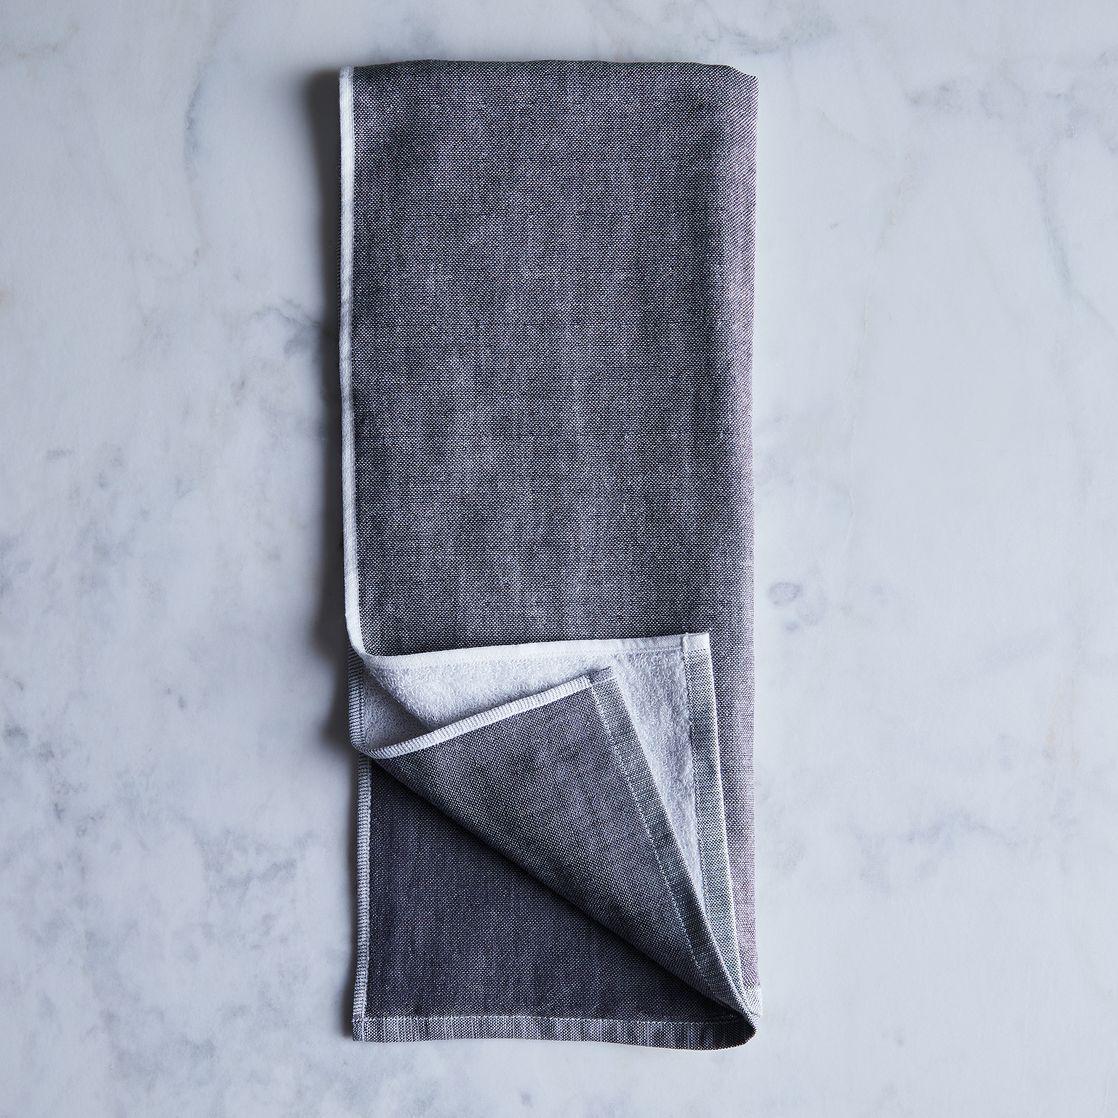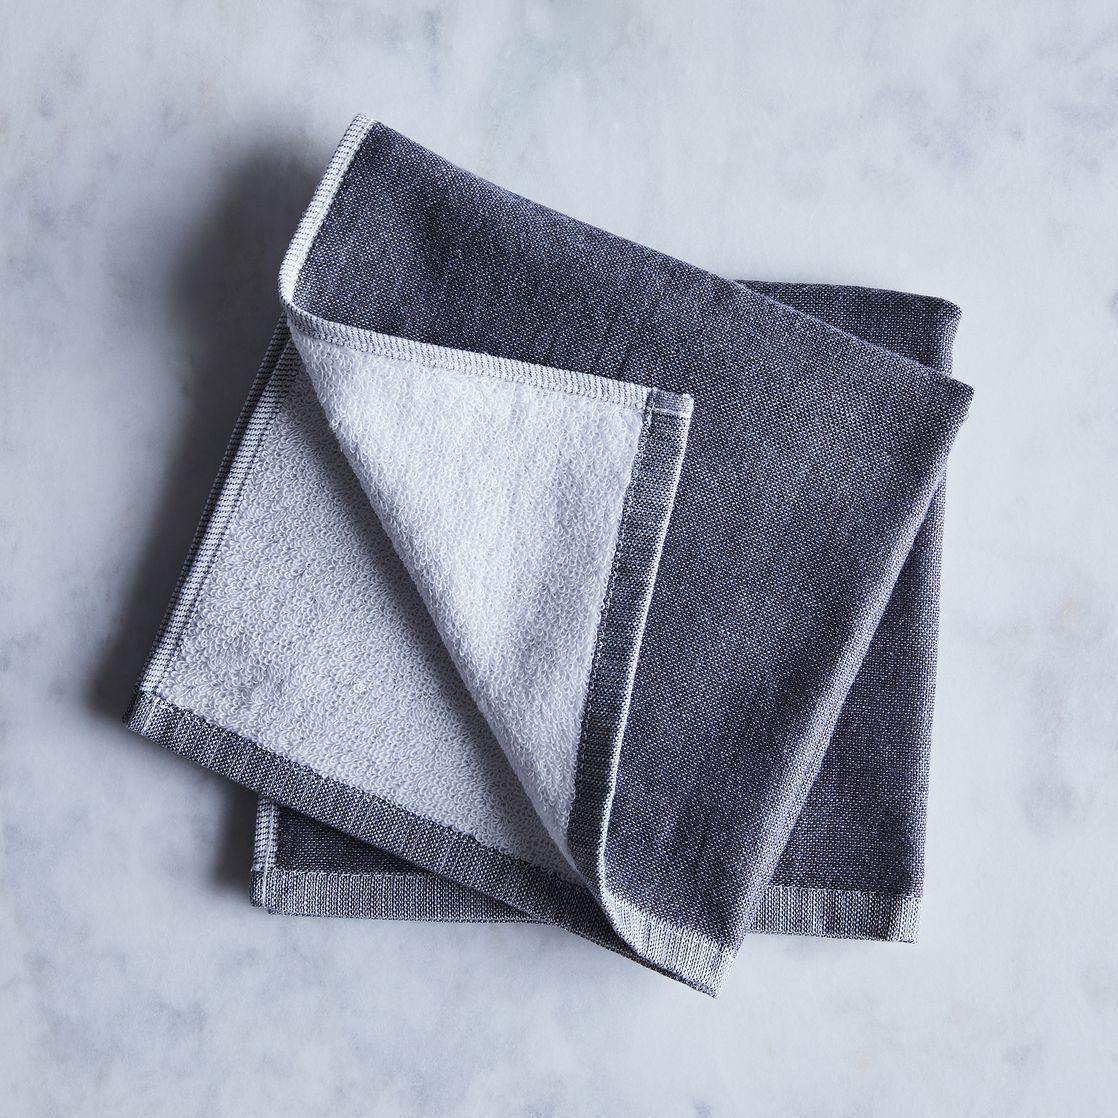The first image is the image on the left, the second image is the image on the right. Examine the images to the left and right. Is the description "One of the images shows a folded gray item with a distinctive weave." accurate? Answer yes or no. No. 